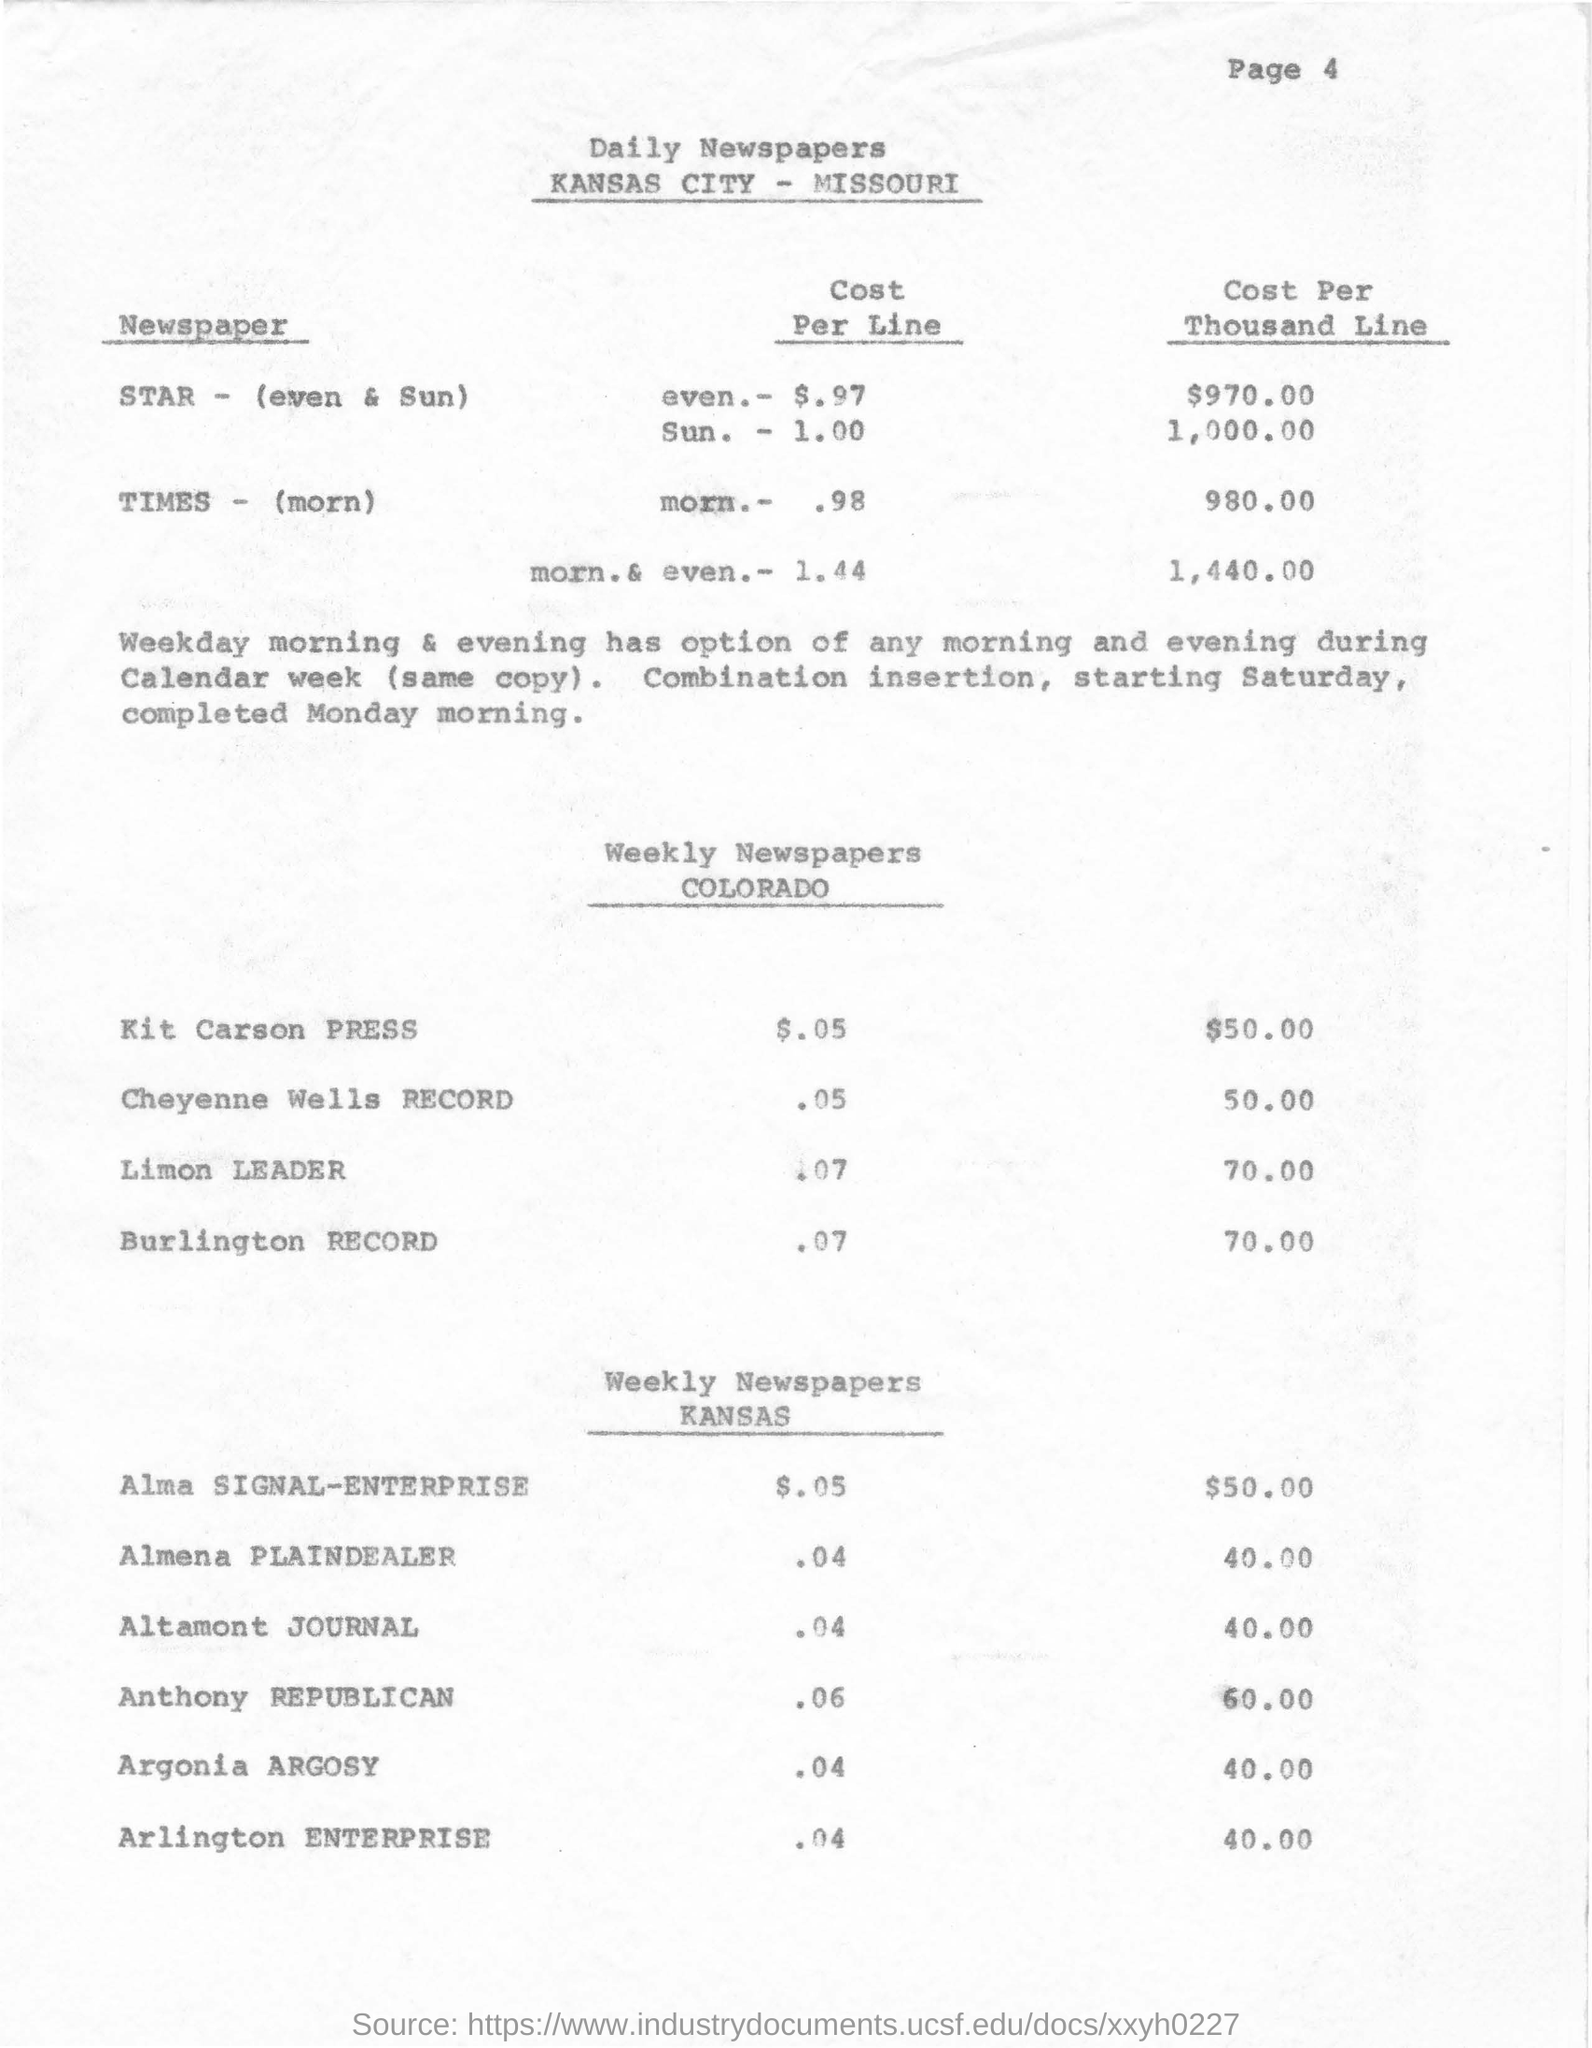Which city is mentioned in the document?
Your answer should be compact. Kansas. How much is the cost per line for kit carson press?
Provide a succinct answer. $.05. How much is the cost per thousand line for Anthony Republican in Kansas?
Offer a very short reply. 60.00. 